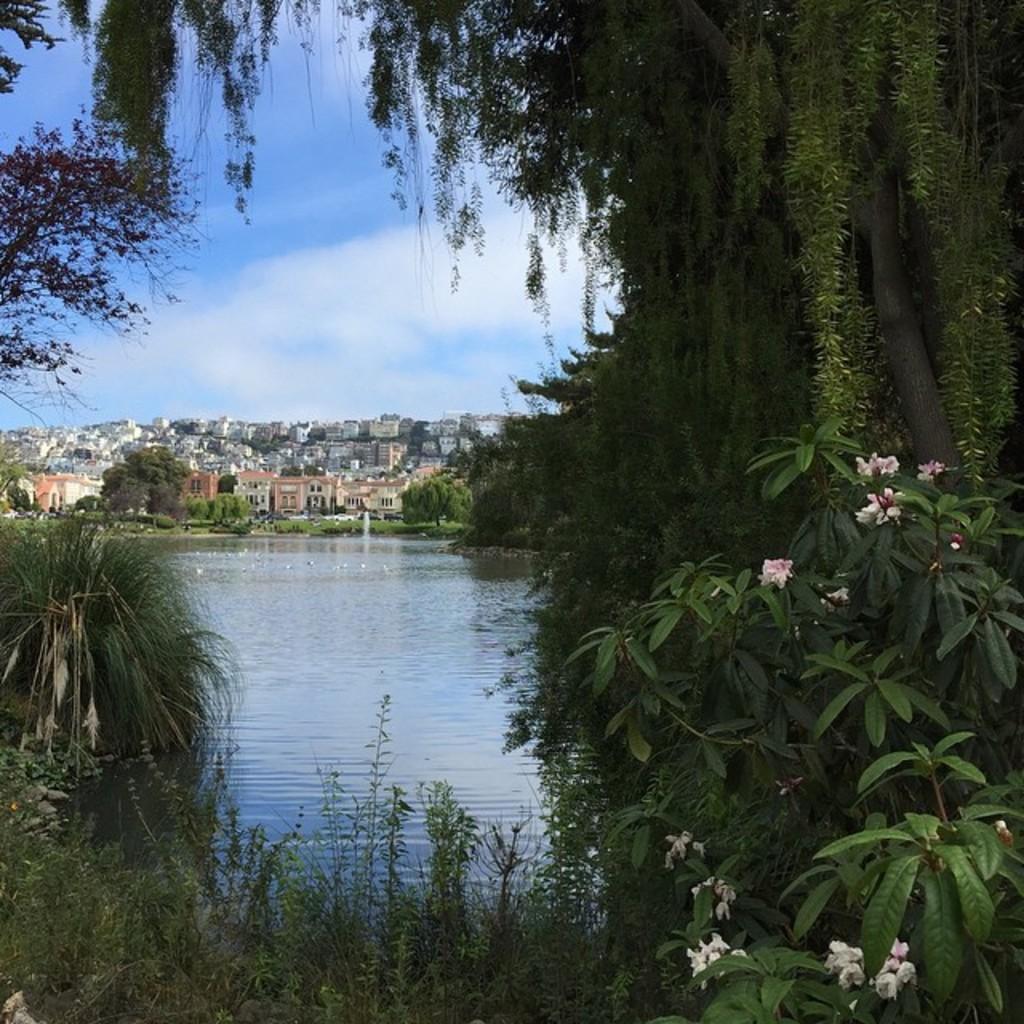Can you describe this image briefly? In the foreground of this image we can see group of flowers on plants , lake with water and group of trees. In the background, we can see group of buildings and the cloudy sky. 